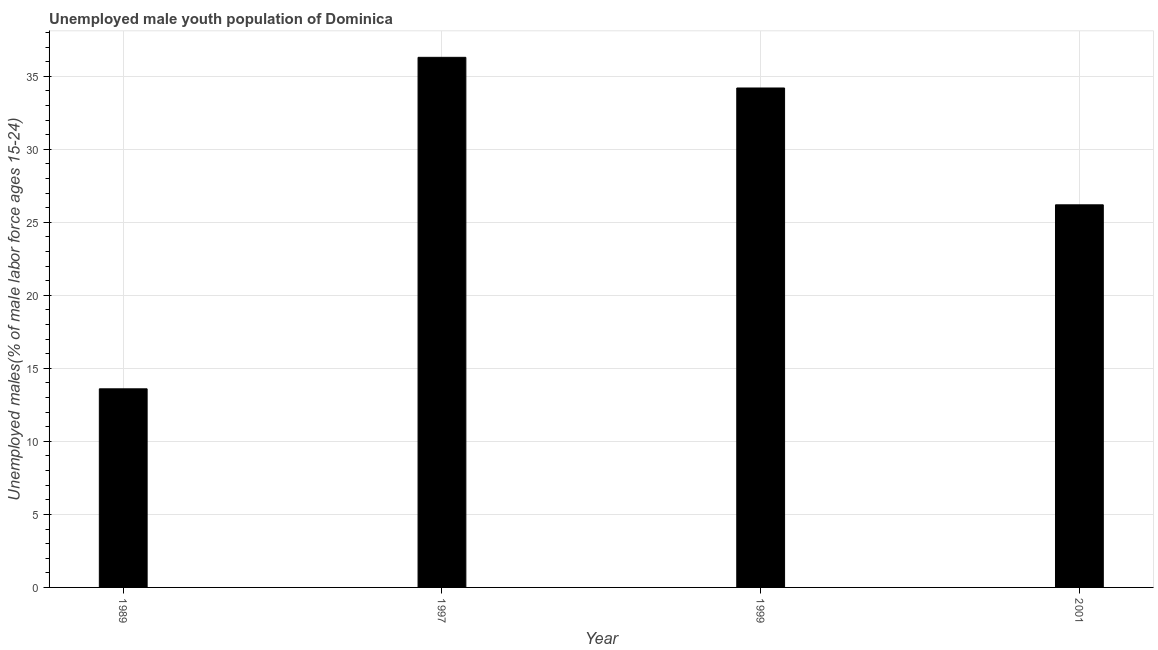Does the graph contain any zero values?
Your answer should be very brief. No. Does the graph contain grids?
Provide a succinct answer. Yes. What is the title of the graph?
Your answer should be compact. Unemployed male youth population of Dominica. What is the label or title of the X-axis?
Your answer should be very brief. Year. What is the label or title of the Y-axis?
Keep it short and to the point. Unemployed males(% of male labor force ages 15-24). What is the unemployed male youth in 1997?
Make the answer very short. 36.3. Across all years, what is the maximum unemployed male youth?
Keep it short and to the point. 36.3. Across all years, what is the minimum unemployed male youth?
Your response must be concise. 13.6. In which year was the unemployed male youth maximum?
Your answer should be very brief. 1997. What is the sum of the unemployed male youth?
Make the answer very short. 110.3. What is the average unemployed male youth per year?
Your answer should be very brief. 27.57. What is the median unemployed male youth?
Keep it short and to the point. 30.2. In how many years, is the unemployed male youth greater than 34 %?
Your answer should be very brief. 2. What is the ratio of the unemployed male youth in 1989 to that in 1999?
Provide a short and direct response. 0.4. Is the difference between the unemployed male youth in 1989 and 1999 greater than the difference between any two years?
Ensure brevity in your answer.  No. What is the difference between the highest and the second highest unemployed male youth?
Ensure brevity in your answer.  2.1. What is the difference between the highest and the lowest unemployed male youth?
Keep it short and to the point. 22.7. In how many years, is the unemployed male youth greater than the average unemployed male youth taken over all years?
Ensure brevity in your answer.  2. How many bars are there?
Your answer should be compact. 4. How many years are there in the graph?
Your response must be concise. 4. What is the difference between two consecutive major ticks on the Y-axis?
Offer a terse response. 5. What is the Unemployed males(% of male labor force ages 15-24) in 1989?
Give a very brief answer. 13.6. What is the Unemployed males(% of male labor force ages 15-24) of 1997?
Provide a succinct answer. 36.3. What is the Unemployed males(% of male labor force ages 15-24) of 1999?
Your answer should be very brief. 34.2. What is the Unemployed males(% of male labor force ages 15-24) in 2001?
Your answer should be compact. 26.2. What is the difference between the Unemployed males(% of male labor force ages 15-24) in 1989 and 1997?
Offer a very short reply. -22.7. What is the difference between the Unemployed males(% of male labor force ages 15-24) in 1989 and 1999?
Offer a terse response. -20.6. What is the difference between the Unemployed males(% of male labor force ages 15-24) in 1997 and 2001?
Give a very brief answer. 10.1. What is the ratio of the Unemployed males(% of male labor force ages 15-24) in 1989 to that in 1999?
Provide a short and direct response. 0.4. What is the ratio of the Unemployed males(% of male labor force ages 15-24) in 1989 to that in 2001?
Your answer should be very brief. 0.52. What is the ratio of the Unemployed males(% of male labor force ages 15-24) in 1997 to that in 1999?
Give a very brief answer. 1.06. What is the ratio of the Unemployed males(% of male labor force ages 15-24) in 1997 to that in 2001?
Your response must be concise. 1.39. What is the ratio of the Unemployed males(% of male labor force ages 15-24) in 1999 to that in 2001?
Your answer should be very brief. 1.3. 